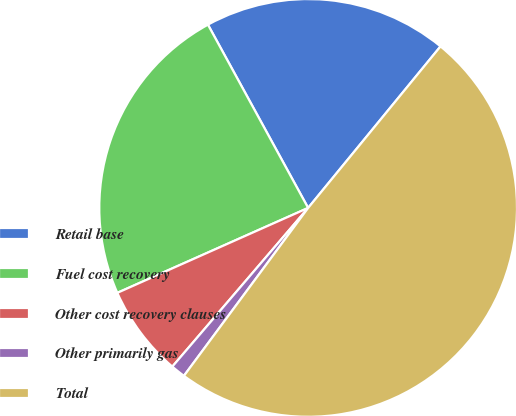Convert chart. <chart><loc_0><loc_0><loc_500><loc_500><pie_chart><fcel>Retail base<fcel>Fuel cost recovery<fcel>Other cost recovery clauses<fcel>Other primarily gas<fcel>Total<nl><fcel>18.89%<fcel>23.7%<fcel>7.07%<fcel>1.13%<fcel>49.21%<nl></chart> 